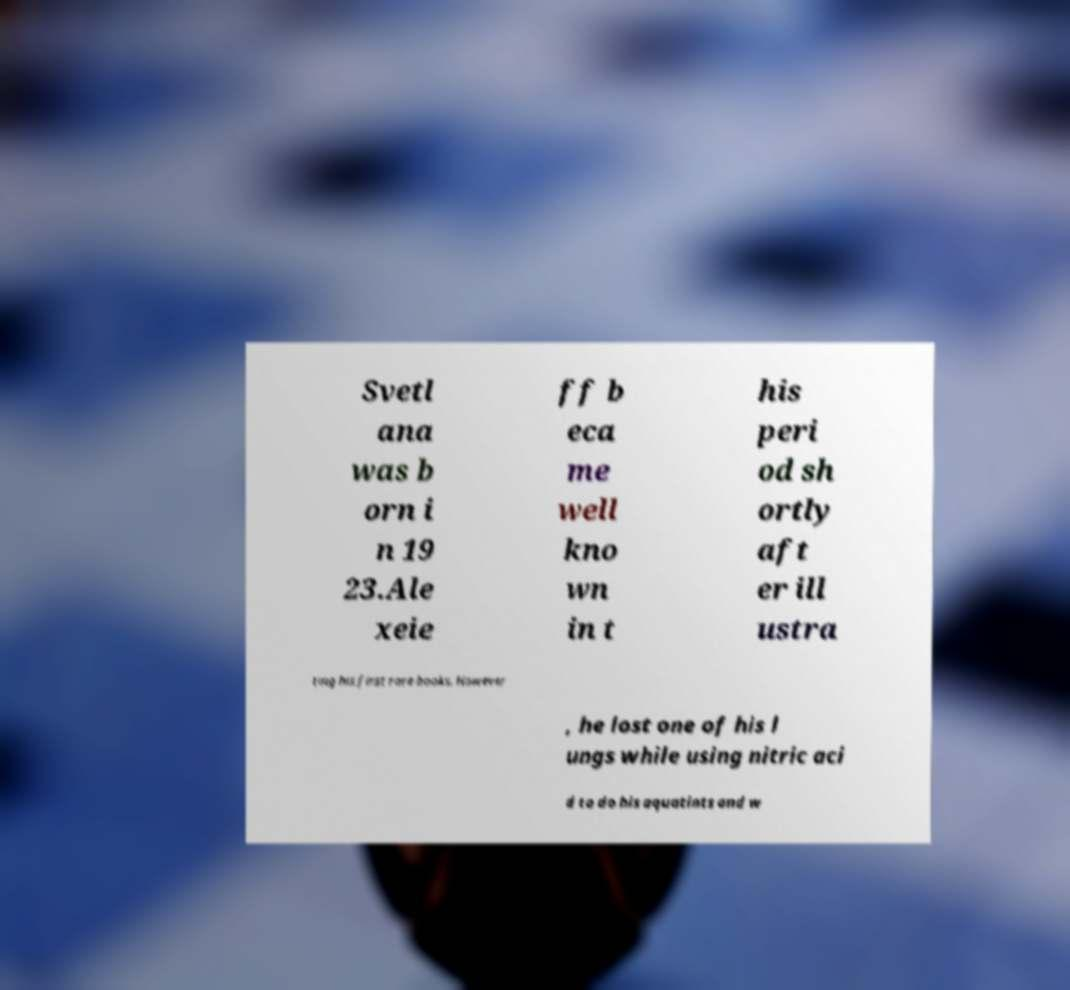Please read and relay the text visible in this image. What does it say? Svetl ana was b orn i n 19 23.Ale xeie ff b eca me well kno wn in t his peri od sh ortly aft er ill ustra ting his first rare books. However , he lost one of his l ungs while using nitric aci d to do his aquatints and w 